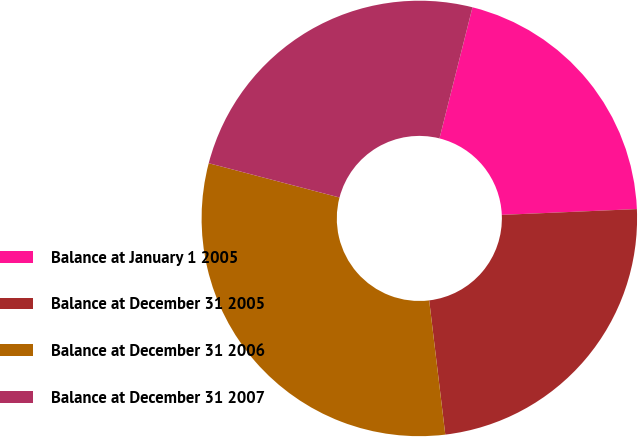Convert chart to OTSL. <chart><loc_0><loc_0><loc_500><loc_500><pie_chart><fcel>Balance at January 1 2005<fcel>Balance at December 31 2005<fcel>Balance at December 31 2006<fcel>Balance at December 31 2007<nl><fcel>20.39%<fcel>23.78%<fcel>30.98%<fcel>24.84%<nl></chart> 